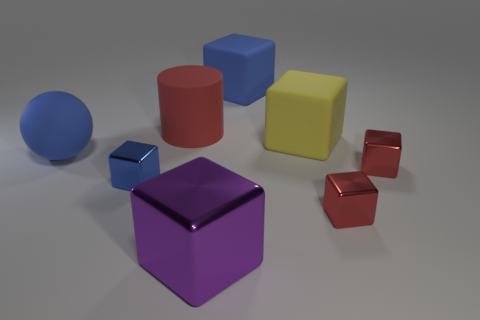Subtract all red metallic blocks. How many blocks are left? 4 Subtract all yellow cubes. How many cubes are left? 5 Subtract all brown blocks. Subtract all purple balls. How many blocks are left? 6 Add 2 large shiny cylinders. How many objects exist? 10 Subtract all blocks. How many objects are left? 2 Add 7 red matte things. How many red matte things are left? 8 Add 7 red metal objects. How many red metal objects exist? 9 Subtract 0 gray spheres. How many objects are left? 8 Subtract all blue shiny blocks. Subtract all big matte spheres. How many objects are left? 6 